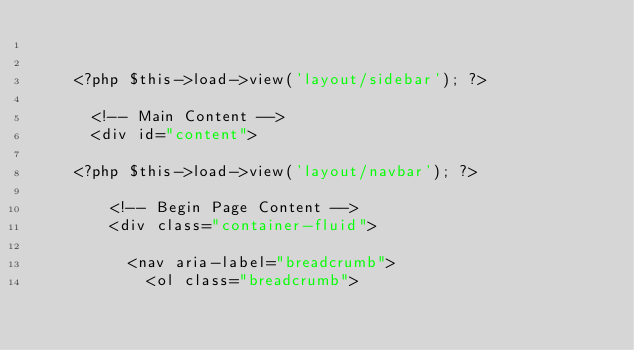<code> <loc_0><loc_0><loc_500><loc_500><_PHP_>

    <?php $this->load->view('layout/sidebar'); ?>

      <!-- Main Content -->
      <div id="content">

    <?php $this->load->view('layout/navbar'); ?>    

        <!-- Begin Page Content -->
        <div class="container-fluid">  

          <nav aria-label="breadcrumb">
            <ol class="breadcrumb"></code> 